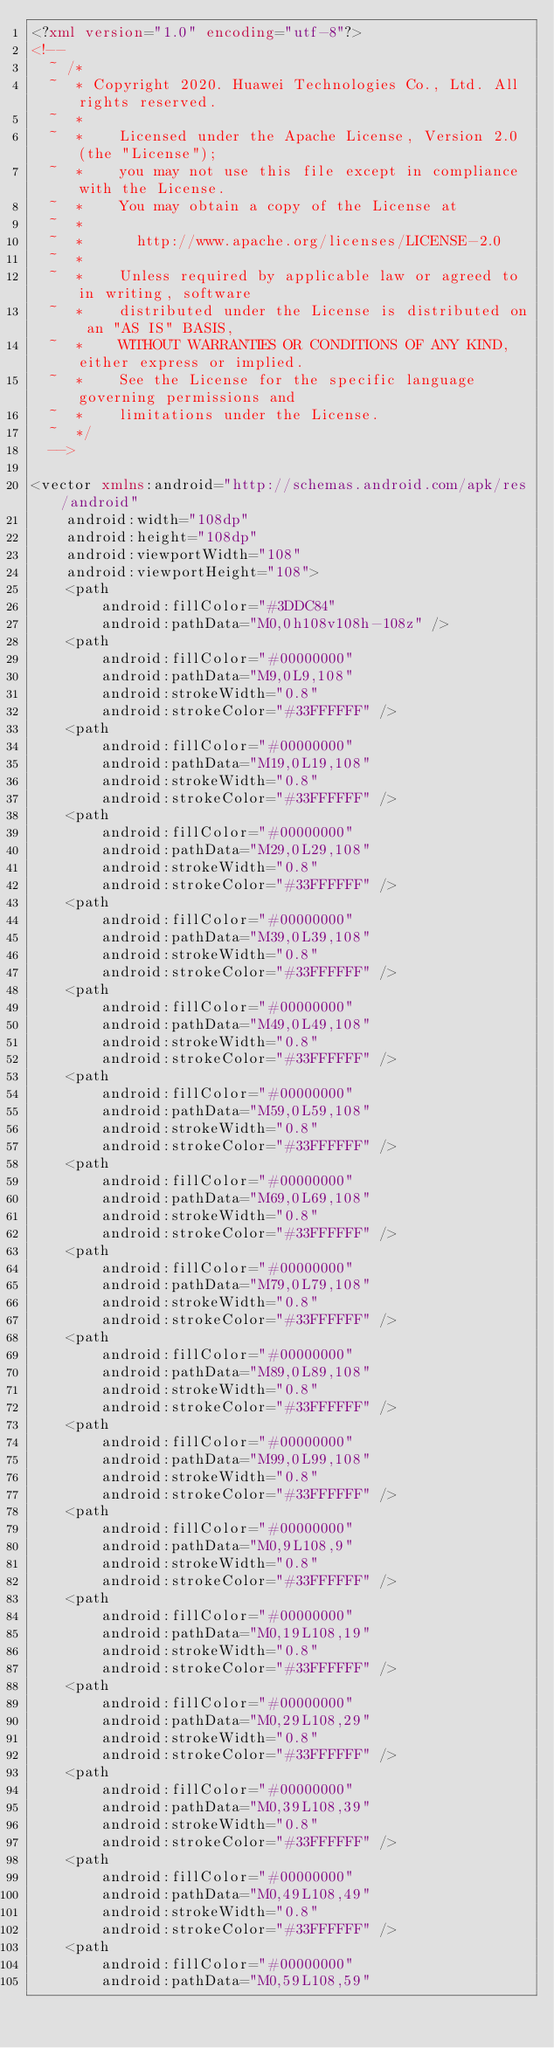Convert code to text. <code><loc_0><loc_0><loc_500><loc_500><_XML_><?xml version="1.0" encoding="utf-8"?>
<!--
  ~ /*
  ~  * Copyright 2020. Huawei Technologies Co., Ltd. All rights reserved.
  ~  *
  ~  *    Licensed under the Apache License, Version 2.0 (the "License");
  ~  *    you may not use this file except in compliance with the License.
  ~  *    You may obtain a copy of the License at
  ~  *
  ~  *      http://www.apache.org/licenses/LICENSE-2.0
  ~  *
  ~  *    Unless required by applicable law or agreed to in writing, software
  ~  *    distributed under the License is distributed on an "AS IS" BASIS,
  ~  *    WITHOUT WARRANTIES OR CONDITIONS OF ANY KIND, either express or implied.
  ~  *    See the License for the specific language governing permissions and
  ~  *    limitations under the License.
  ~  */
  -->

<vector xmlns:android="http://schemas.android.com/apk/res/android"
    android:width="108dp"
    android:height="108dp"
    android:viewportWidth="108"
    android:viewportHeight="108">
    <path
        android:fillColor="#3DDC84"
        android:pathData="M0,0h108v108h-108z" />
    <path
        android:fillColor="#00000000"
        android:pathData="M9,0L9,108"
        android:strokeWidth="0.8"
        android:strokeColor="#33FFFFFF" />
    <path
        android:fillColor="#00000000"
        android:pathData="M19,0L19,108"
        android:strokeWidth="0.8"
        android:strokeColor="#33FFFFFF" />
    <path
        android:fillColor="#00000000"
        android:pathData="M29,0L29,108"
        android:strokeWidth="0.8"
        android:strokeColor="#33FFFFFF" />
    <path
        android:fillColor="#00000000"
        android:pathData="M39,0L39,108"
        android:strokeWidth="0.8"
        android:strokeColor="#33FFFFFF" />
    <path
        android:fillColor="#00000000"
        android:pathData="M49,0L49,108"
        android:strokeWidth="0.8"
        android:strokeColor="#33FFFFFF" />
    <path
        android:fillColor="#00000000"
        android:pathData="M59,0L59,108"
        android:strokeWidth="0.8"
        android:strokeColor="#33FFFFFF" />
    <path
        android:fillColor="#00000000"
        android:pathData="M69,0L69,108"
        android:strokeWidth="0.8"
        android:strokeColor="#33FFFFFF" />
    <path
        android:fillColor="#00000000"
        android:pathData="M79,0L79,108"
        android:strokeWidth="0.8"
        android:strokeColor="#33FFFFFF" />
    <path
        android:fillColor="#00000000"
        android:pathData="M89,0L89,108"
        android:strokeWidth="0.8"
        android:strokeColor="#33FFFFFF" />
    <path
        android:fillColor="#00000000"
        android:pathData="M99,0L99,108"
        android:strokeWidth="0.8"
        android:strokeColor="#33FFFFFF" />
    <path
        android:fillColor="#00000000"
        android:pathData="M0,9L108,9"
        android:strokeWidth="0.8"
        android:strokeColor="#33FFFFFF" />
    <path
        android:fillColor="#00000000"
        android:pathData="M0,19L108,19"
        android:strokeWidth="0.8"
        android:strokeColor="#33FFFFFF" />
    <path
        android:fillColor="#00000000"
        android:pathData="M0,29L108,29"
        android:strokeWidth="0.8"
        android:strokeColor="#33FFFFFF" />
    <path
        android:fillColor="#00000000"
        android:pathData="M0,39L108,39"
        android:strokeWidth="0.8"
        android:strokeColor="#33FFFFFF" />
    <path
        android:fillColor="#00000000"
        android:pathData="M0,49L108,49"
        android:strokeWidth="0.8"
        android:strokeColor="#33FFFFFF" />
    <path
        android:fillColor="#00000000"
        android:pathData="M0,59L108,59"</code> 